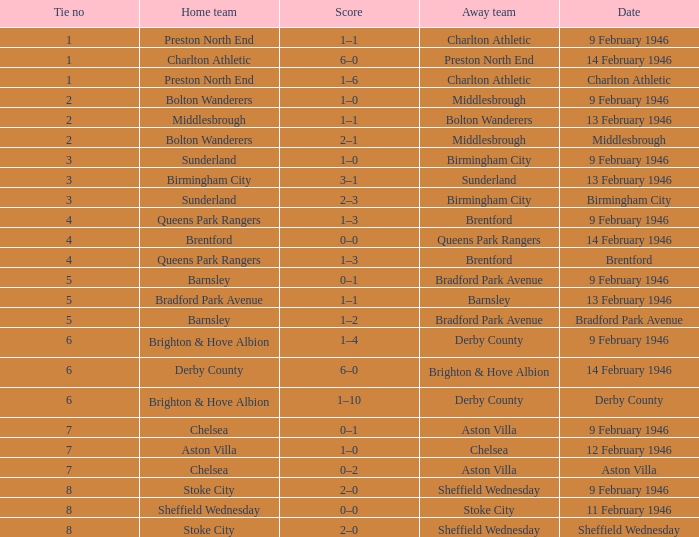What is the typical tie number when the date is birmingham city? 3.0. Help me parse the entirety of this table. {'header': ['Tie no', 'Home team', 'Score', 'Away team', 'Date'], 'rows': [['1', 'Preston North End', '1–1', 'Charlton Athletic', '9 February 1946'], ['1', 'Charlton Athletic', '6–0', 'Preston North End', '14 February 1946'], ['1', 'Preston North End', '1–6', 'Charlton Athletic', 'Charlton Athletic'], ['2', 'Bolton Wanderers', '1–0', 'Middlesbrough', '9 February 1946'], ['2', 'Middlesbrough', '1–1', 'Bolton Wanderers', '13 February 1946'], ['2', 'Bolton Wanderers', '2–1', 'Middlesbrough', 'Middlesbrough'], ['3', 'Sunderland', '1–0', 'Birmingham City', '9 February 1946'], ['3', 'Birmingham City', '3–1', 'Sunderland', '13 February 1946'], ['3', 'Sunderland', '2–3', 'Birmingham City', 'Birmingham City'], ['4', 'Queens Park Rangers', '1–3', 'Brentford', '9 February 1946'], ['4', 'Brentford', '0–0', 'Queens Park Rangers', '14 February 1946'], ['4', 'Queens Park Rangers', '1–3', 'Brentford', 'Brentford'], ['5', 'Barnsley', '0–1', 'Bradford Park Avenue', '9 February 1946'], ['5', 'Bradford Park Avenue', '1–1', 'Barnsley', '13 February 1946'], ['5', 'Barnsley', '1–2', 'Bradford Park Avenue', 'Bradford Park Avenue'], ['6', 'Brighton & Hove Albion', '1–4', 'Derby County', '9 February 1946'], ['6', 'Derby County', '6–0', 'Brighton & Hove Albion', '14 February 1946'], ['6', 'Brighton & Hove Albion', '1–10', 'Derby County', 'Derby County'], ['7', 'Chelsea', '0–1', 'Aston Villa', '9 February 1946'], ['7', 'Aston Villa', '1–0', 'Chelsea', '12 February 1946'], ['7', 'Chelsea', '0–2', 'Aston Villa', 'Aston Villa'], ['8', 'Stoke City', '2–0', 'Sheffield Wednesday', '9 February 1946'], ['8', 'Sheffield Wednesday', '0–0', 'Stoke City', '11 February 1946'], ['8', 'Stoke City', '2–0', 'Sheffield Wednesday', 'Sheffield Wednesday']]} 